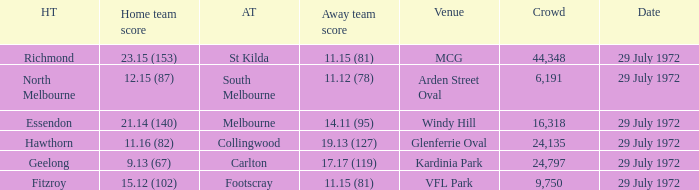When did the visiting team footscray achieve 1 29 July 1972. 